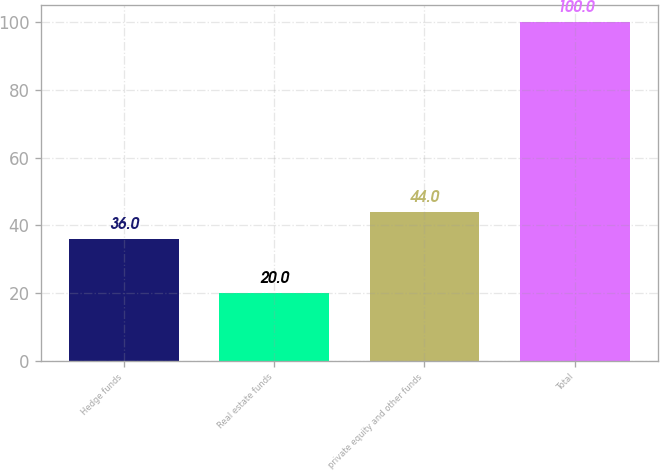Convert chart. <chart><loc_0><loc_0><loc_500><loc_500><bar_chart><fcel>Hedge funds<fcel>Real estate funds<fcel>private equity and other funds<fcel>Total<nl><fcel>36<fcel>20<fcel>44<fcel>100<nl></chart> 